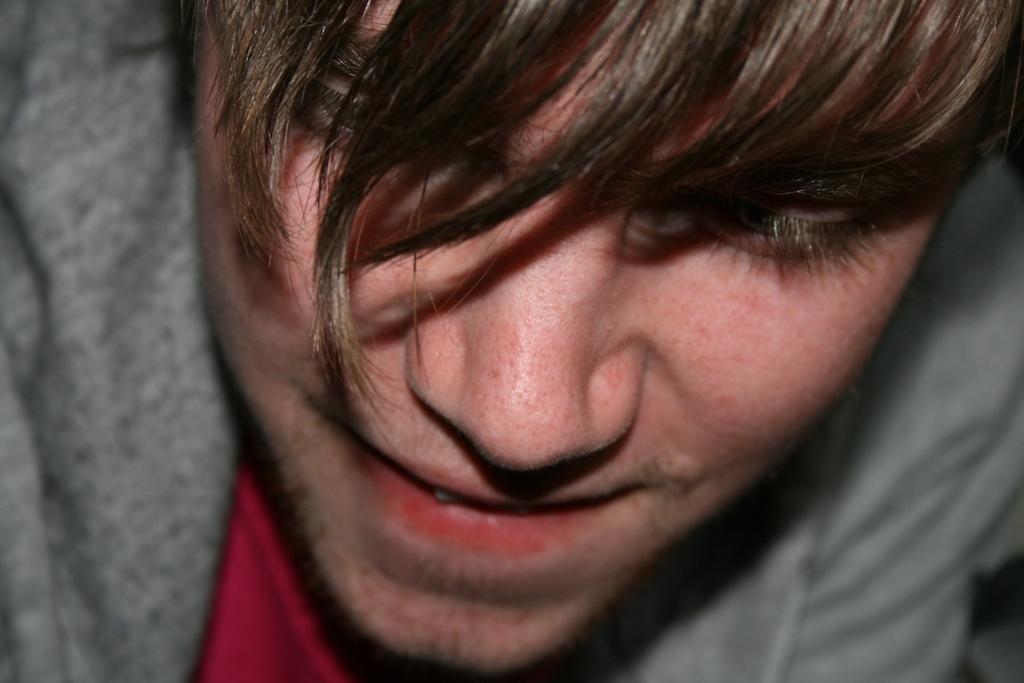In one or two sentences, can you explain what this image depicts? As we can see in the image there is a man wearing brown color jacket. 